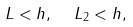<formula> <loc_0><loc_0><loc_500><loc_500>L < h , \ \ L _ { 2 } < h ,</formula> 